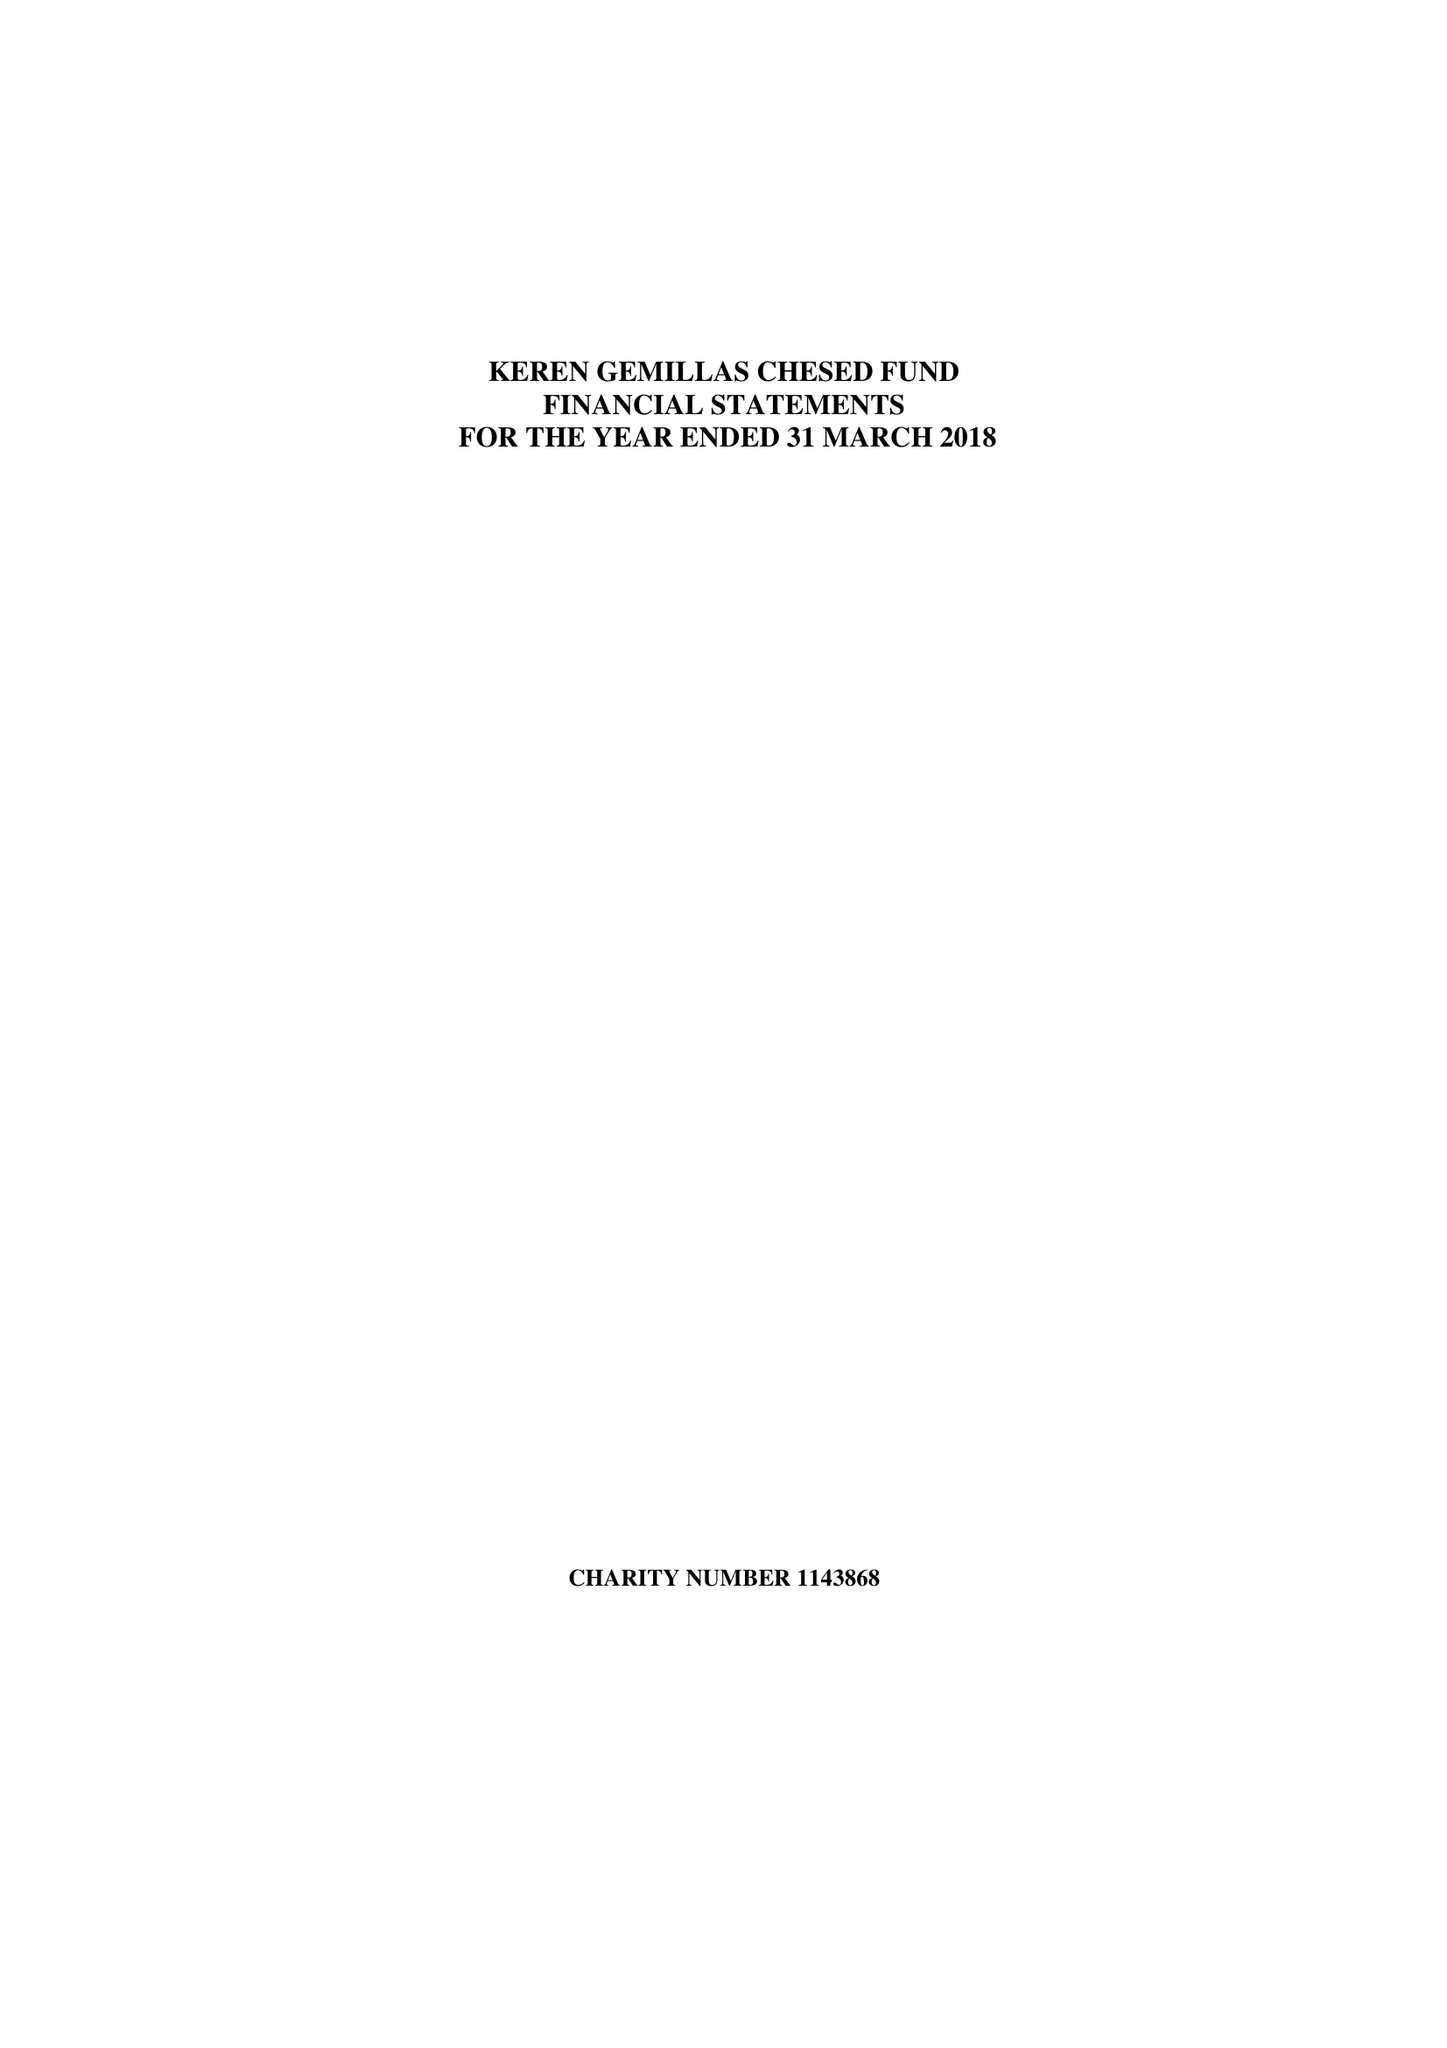What is the value for the report_date?
Answer the question using a single word or phrase. 2018-03-31 